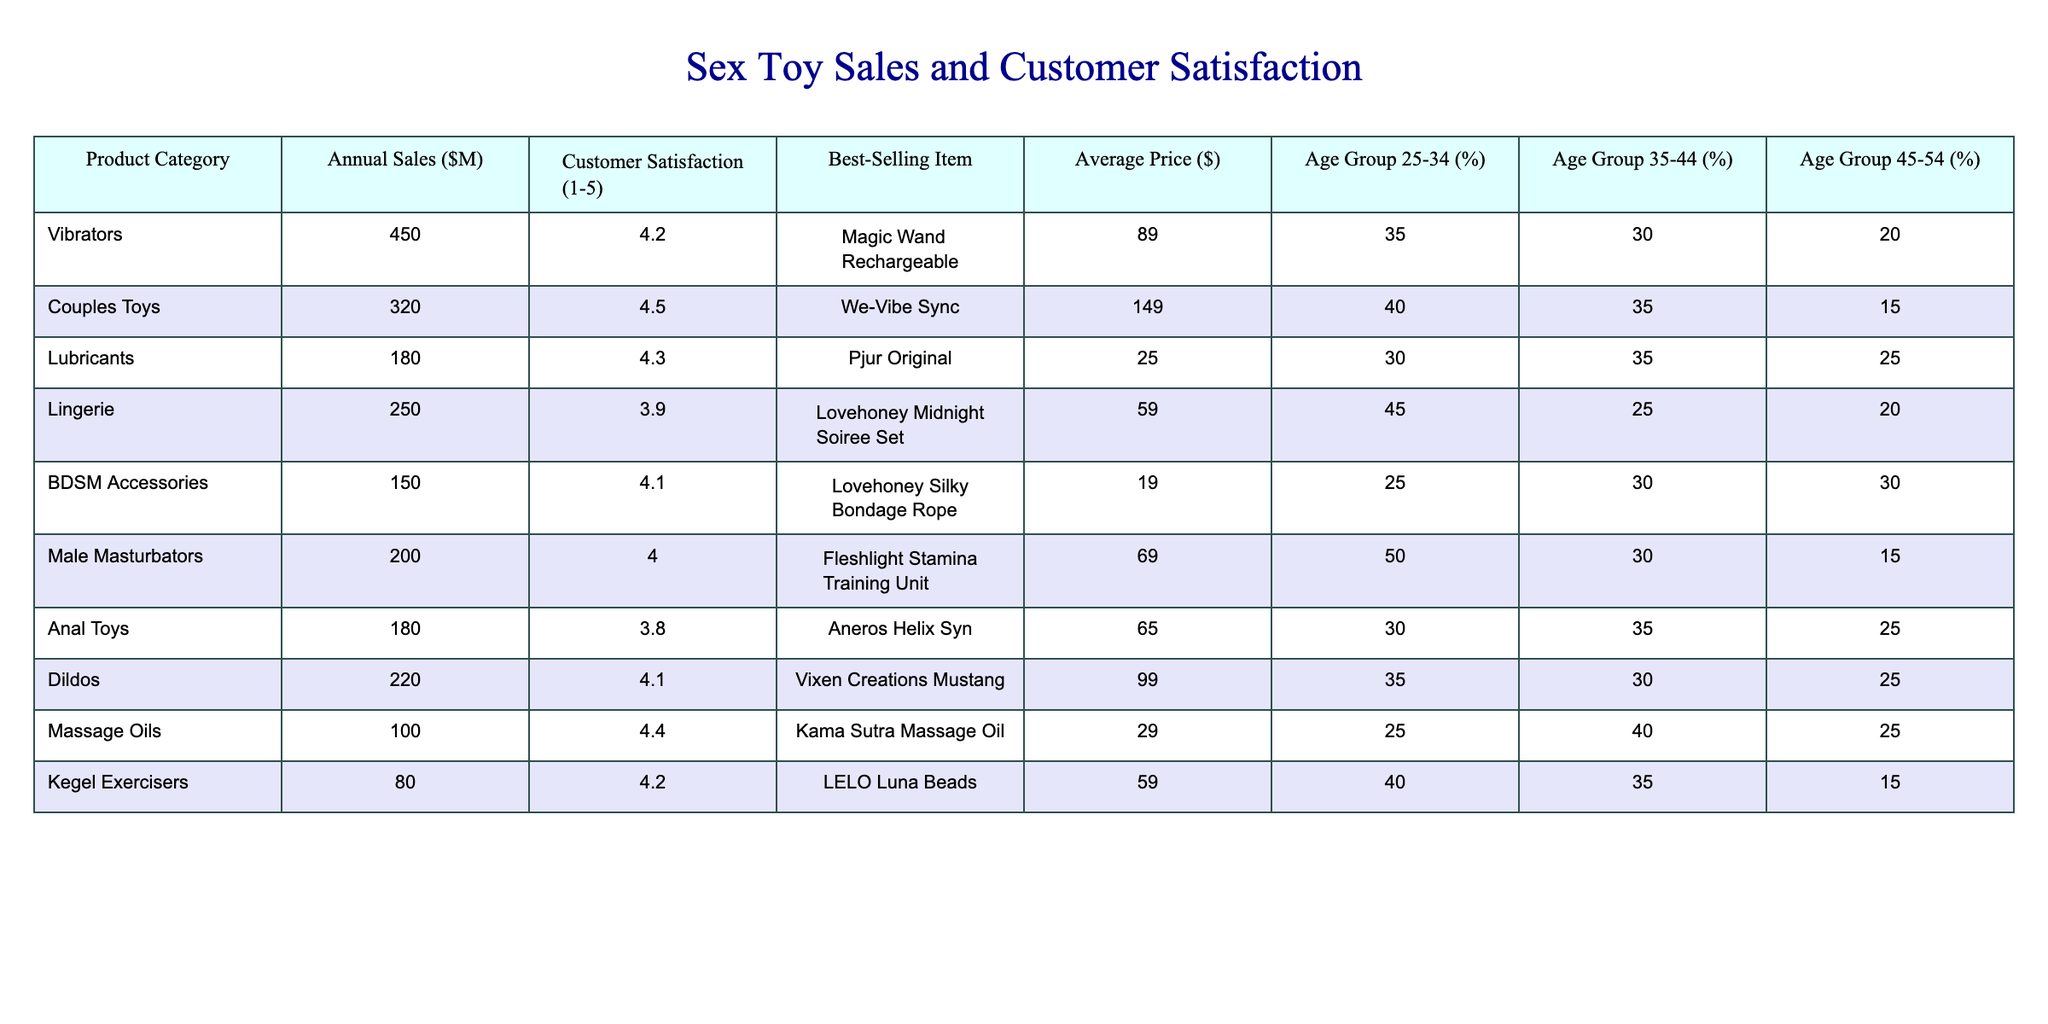What is the best-selling item in the Couples Toys category? The Couples Toys category has a best-selling item listed in the table, which is the We-Vibe Sync.
Answer: We-Vibe Sync Which product category has the highest customer satisfaction rating? Looking through the customer satisfaction ratings, Couples Toys has the highest rating of 4.5 out of 5.
Answer: Couples Toys What is the average customer satisfaction rating of all categories? To find the average, we sum the customer satisfaction ratings: (4.2 + 4.5 + 4.3 + 3.9 + 4.1 + 4.0 + 3.8 + 4.1 + 4.4 + 4.2) = 42.6. There are 10 categories, so the average is 42.6/10 = 4.26.
Answer: 4.26 Which age group is most represented in the Male Masturbators category? The table shows that for Male Masturbators, 50% of the customers belong to the 25-34 age group, which is the highest percentage for this category.
Answer: 25-34 age group How many product categories have customer satisfaction ratings above 4.0? By examining the ratings in the table, the product categories with ratings above 4.0 are: Vibrators (4.2), Couples Toys (4.5), Lubricants (4.3), BDSM Accessories (4.1), Male Masturbators (4.0), Dildos (4.1), Massage Oils (4.4), and Kegel Exercisers (4.2). Counting these, we find 8 categories have ratings above 4.0.
Answer: 8 categories What is the difference in annual sales between the highest and lowest product categories? The highest sales category is Vibrators with $450M and the lowest is Kegel Exercisers with $80M. The difference in sales is 450 - 80 = 370.
Answer: $370M Are there more products targeted towards the 45-54 age group or the 25-34 age group? The table shows that the percentages for each age group across all categories are as follows: 45-54 age group totals up to 20% + 15% + 25% + 30% + 15% = 105%, whereas the 25-34 age group totals to 35% + 40% + 30% + 25% + 50% + 40% = 220%. Thus, there are more products targeting the 25-34 age group.
Answer: Yes, more products target the 25-34 age group Which product category has a lower average price than Lubricants? The average price of Lubricants is $25. The table shows that BDSM Accessories ($19), and Kegel Exercisers ($59) have lower prices than Lubricants. However, Kegel Exercisers price exceeds Lubricants, leaving only BDSM Accessories as lower.
Answer: BDSM Accessories What is the total annual sales of the categories with a customer satisfaction above 4.0? The categories with a satisfaction rating above 4.0 are: Vibrators ($450M), Couples Toys ($320M), Lubricants ($180M), BDSM Accessories ($150M), Male Masturbators ($200M), Dildos ($220M), Massage Oils ($100M), and Kegel Exercisers ($80M). Summing up their sales: 450 + 320 + 180 + 150 + 200 + 220 + 100 + 80 = 1700.
Answer: $1700M In which product category do customers aged 35-44 represent the highest percentage? From the data in the table, Couples Toys has the highest percentage of 35% in the 35-44 age group compared to all other categories.
Answer: Couples Toys 